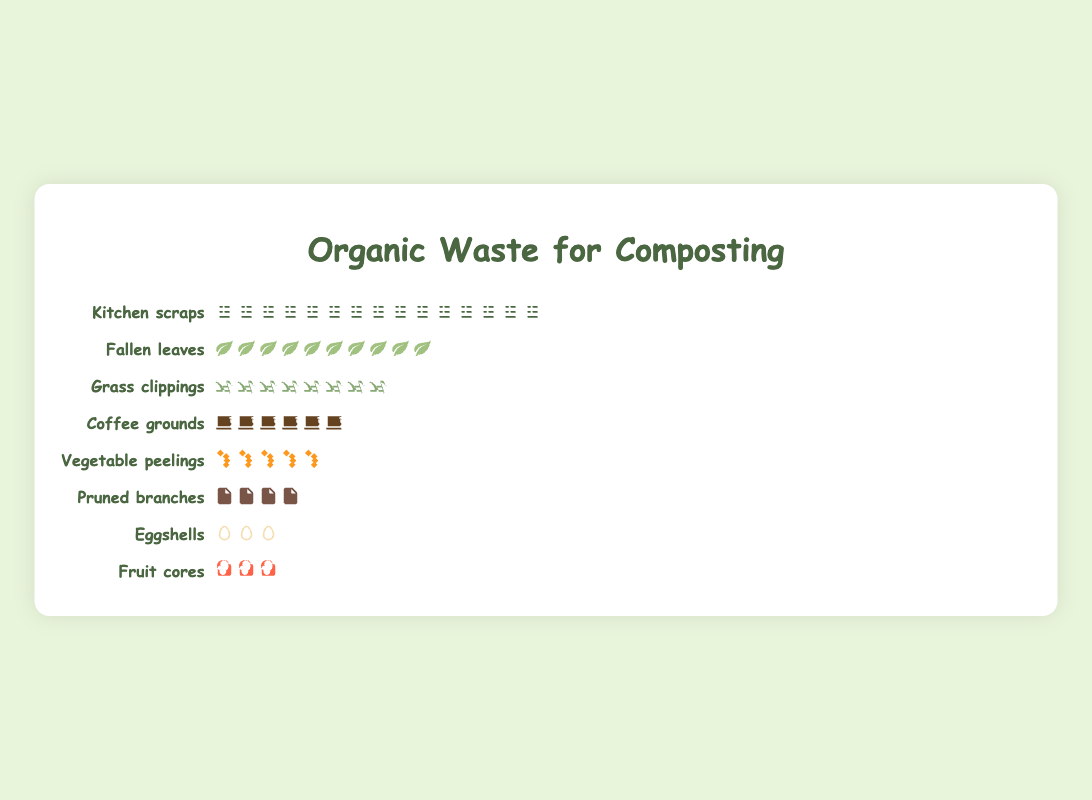What is the title of the figure? The title of the figure is usually found at the top. In this particular plot, it states "Organic Waste for Composting" in a prominent and larger font style.
Answer: Organic Waste for Composting How many icons represent "Kitchen scraps"? Each icon represents a certain number of items, and for "Kitchen scraps," it's easy to count all the individual icons beside the label.
Answer: 15 Which type of organic waste has the fewest items collected? To determine this, scan across all the rows and notice which type has the least number of icons associated.
Answer: Fruit cores How many types of organic waste are listed in the Isotype plot? Count the distinct row labels in the plot, each representing a different type of organic waste.
Answer: 8 What item is represented by a background image with brown color and vertical squares? Observe the icon with a unique brown color and square design, identify the label in that row.
Answer: Coffee grounds Which type of organic waste has four icons displayed beside it? Look for the row showing exactly four icon shapes in its section.
Answer: Pruned branches Are there more "Eggshells" or "Coffee grounds" collected? Count the icons beside each label and compare their numbers.
Answer: Coffee grounds How many icons represent both "Vegetable peelings" and "Fruit cores" together? Sum the icons from the rows labeled "Vegetable peelings" and "Fruit cores" by adding 5 for Vegetable peelings and 3 for Fruit cores.
Answer: 8 Which type of waste is represented by orange, angular icon diagrams? Find the icons with a distinctive orange color and angular design, then check the row label they are next to.
Answer: Vegetable peelings 